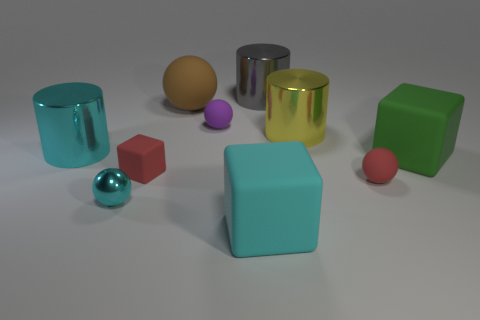Do the green object and the brown rubber ball have the same size?
Keep it short and to the point. Yes. What number of rubber objects are either large blue blocks or big yellow objects?
Ensure brevity in your answer.  0. There is a cube that is the same size as the purple object; what is its material?
Provide a succinct answer. Rubber. How many other things are made of the same material as the cyan cylinder?
Your answer should be very brief. 3. Is the number of small red objects that are behind the green block less than the number of big matte objects?
Provide a succinct answer. Yes. Is the shape of the brown object the same as the green rubber thing?
Offer a terse response. No. How big is the cyan metal thing that is behind the green rubber block that is behind the large matte block that is to the left of the small red ball?
Your answer should be compact. Large. There is a red thing that is the same shape as the cyan matte object; what is its material?
Your answer should be very brief. Rubber. What size is the rubber ball that is in front of the large cylinder that is on the left side of the cyan metal sphere?
Give a very brief answer. Small. The big matte ball is what color?
Keep it short and to the point. Brown. 